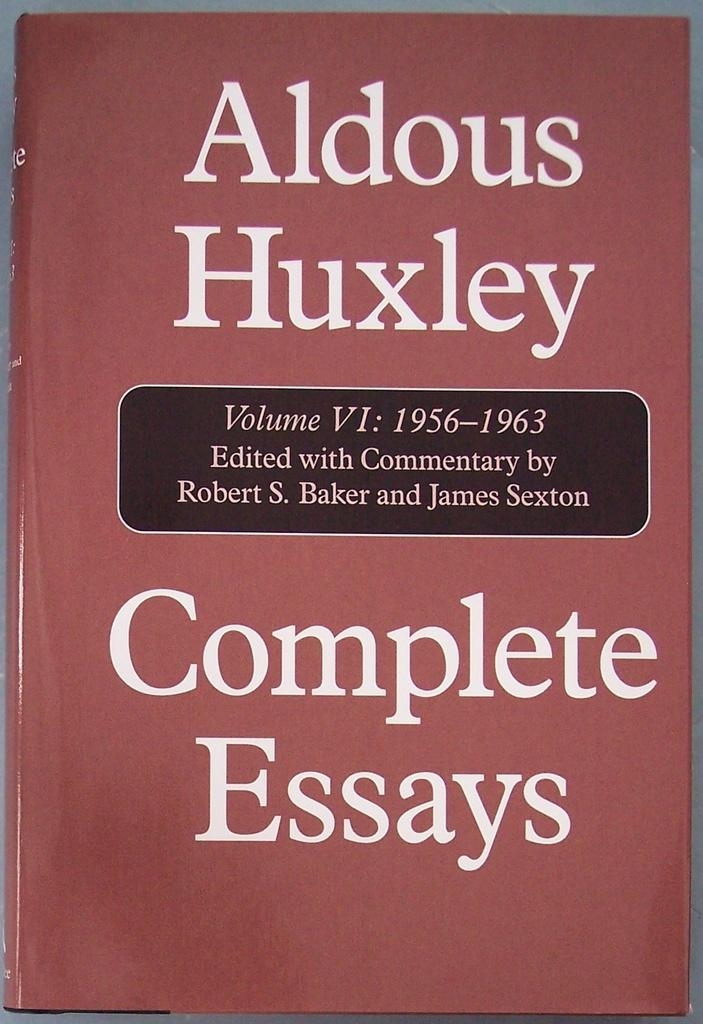<image>
Relay a brief, clear account of the picture shown. A book with a rose color contains essays by Aldous Huxley. 